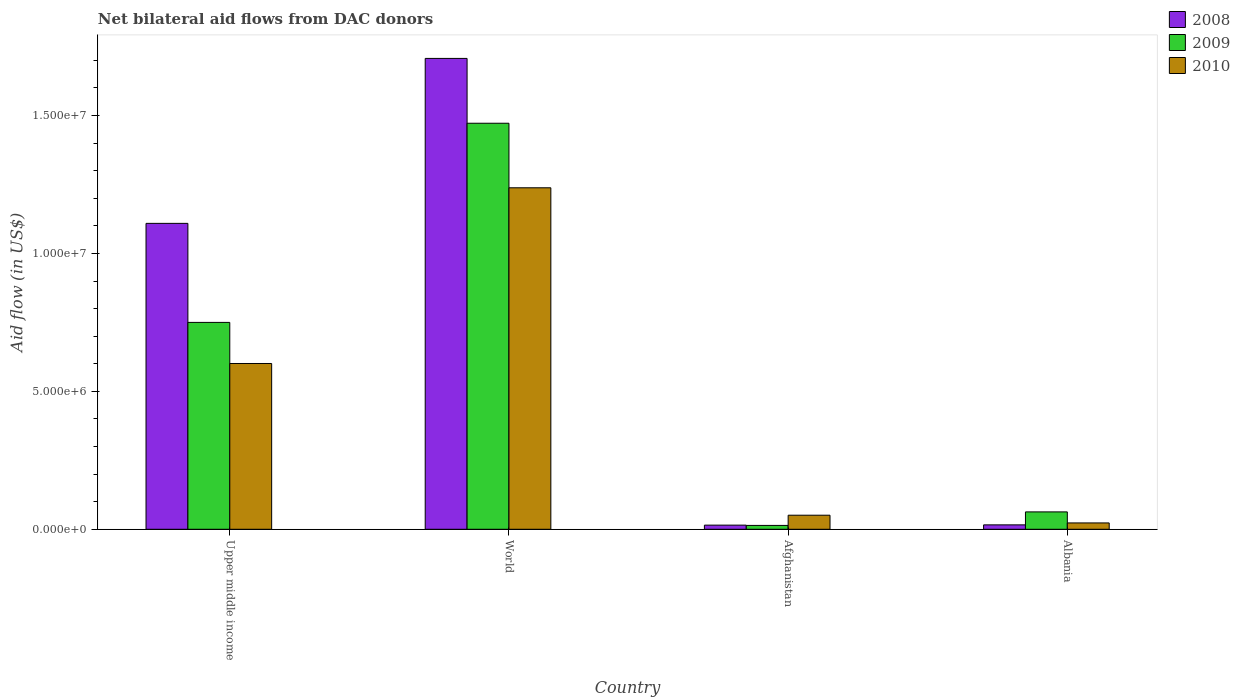Are the number of bars per tick equal to the number of legend labels?
Offer a terse response. Yes. How many bars are there on the 4th tick from the left?
Your response must be concise. 3. How many bars are there on the 4th tick from the right?
Your answer should be compact. 3. What is the label of the 3rd group of bars from the left?
Make the answer very short. Afghanistan. In how many cases, is the number of bars for a given country not equal to the number of legend labels?
Your answer should be very brief. 0. What is the net bilateral aid flow in 2009 in Upper middle income?
Provide a short and direct response. 7.50e+06. Across all countries, what is the maximum net bilateral aid flow in 2008?
Give a very brief answer. 1.71e+07. In which country was the net bilateral aid flow in 2008 minimum?
Your response must be concise. Afghanistan. What is the total net bilateral aid flow in 2010 in the graph?
Give a very brief answer. 1.91e+07. What is the difference between the net bilateral aid flow in 2008 in Afghanistan and that in World?
Your response must be concise. -1.69e+07. What is the difference between the net bilateral aid flow in 2009 in Upper middle income and the net bilateral aid flow in 2008 in World?
Your answer should be very brief. -9.57e+06. What is the average net bilateral aid flow in 2008 per country?
Offer a very short reply. 7.12e+06. In how many countries, is the net bilateral aid flow in 2010 greater than 7000000 US$?
Give a very brief answer. 1. What is the ratio of the net bilateral aid flow in 2010 in Upper middle income to that in World?
Your response must be concise. 0.49. Is the net bilateral aid flow in 2008 in Upper middle income less than that in World?
Keep it short and to the point. Yes. Is the difference between the net bilateral aid flow in 2009 in Albania and World greater than the difference between the net bilateral aid flow in 2010 in Albania and World?
Provide a short and direct response. No. What is the difference between the highest and the second highest net bilateral aid flow in 2008?
Offer a terse response. 1.69e+07. What is the difference between the highest and the lowest net bilateral aid flow in 2009?
Your response must be concise. 1.46e+07. In how many countries, is the net bilateral aid flow in 2009 greater than the average net bilateral aid flow in 2009 taken over all countries?
Your response must be concise. 2. Is the sum of the net bilateral aid flow in 2008 in Afghanistan and Upper middle income greater than the maximum net bilateral aid flow in 2009 across all countries?
Give a very brief answer. No. Is it the case that in every country, the sum of the net bilateral aid flow in 2009 and net bilateral aid flow in 2008 is greater than the net bilateral aid flow in 2010?
Provide a succinct answer. No. Are the values on the major ticks of Y-axis written in scientific E-notation?
Your response must be concise. Yes. Does the graph contain any zero values?
Offer a very short reply. No. Does the graph contain grids?
Keep it short and to the point. No. How are the legend labels stacked?
Your answer should be very brief. Vertical. What is the title of the graph?
Your answer should be very brief. Net bilateral aid flows from DAC donors. What is the label or title of the X-axis?
Your response must be concise. Country. What is the label or title of the Y-axis?
Provide a succinct answer. Aid flow (in US$). What is the Aid flow (in US$) in 2008 in Upper middle income?
Give a very brief answer. 1.11e+07. What is the Aid flow (in US$) in 2009 in Upper middle income?
Keep it short and to the point. 7.50e+06. What is the Aid flow (in US$) in 2010 in Upper middle income?
Offer a very short reply. 6.01e+06. What is the Aid flow (in US$) of 2008 in World?
Your answer should be compact. 1.71e+07. What is the Aid flow (in US$) in 2009 in World?
Your response must be concise. 1.47e+07. What is the Aid flow (in US$) in 2010 in World?
Your response must be concise. 1.24e+07. What is the Aid flow (in US$) in 2008 in Afghanistan?
Your answer should be compact. 1.50e+05. What is the Aid flow (in US$) of 2010 in Afghanistan?
Your answer should be compact. 5.10e+05. What is the Aid flow (in US$) in 2009 in Albania?
Give a very brief answer. 6.30e+05. What is the Aid flow (in US$) in 2010 in Albania?
Your answer should be very brief. 2.30e+05. Across all countries, what is the maximum Aid flow (in US$) of 2008?
Make the answer very short. 1.71e+07. Across all countries, what is the maximum Aid flow (in US$) of 2009?
Provide a short and direct response. 1.47e+07. Across all countries, what is the maximum Aid flow (in US$) of 2010?
Give a very brief answer. 1.24e+07. Across all countries, what is the minimum Aid flow (in US$) in 2008?
Ensure brevity in your answer.  1.50e+05. Across all countries, what is the minimum Aid flow (in US$) in 2010?
Your answer should be compact. 2.30e+05. What is the total Aid flow (in US$) in 2008 in the graph?
Your answer should be compact. 2.85e+07. What is the total Aid flow (in US$) in 2009 in the graph?
Make the answer very short. 2.30e+07. What is the total Aid flow (in US$) in 2010 in the graph?
Give a very brief answer. 1.91e+07. What is the difference between the Aid flow (in US$) of 2008 in Upper middle income and that in World?
Offer a terse response. -5.98e+06. What is the difference between the Aid flow (in US$) in 2009 in Upper middle income and that in World?
Offer a very short reply. -7.22e+06. What is the difference between the Aid flow (in US$) of 2010 in Upper middle income and that in World?
Offer a terse response. -6.37e+06. What is the difference between the Aid flow (in US$) in 2008 in Upper middle income and that in Afghanistan?
Your response must be concise. 1.09e+07. What is the difference between the Aid flow (in US$) of 2009 in Upper middle income and that in Afghanistan?
Offer a terse response. 7.36e+06. What is the difference between the Aid flow (in US$) of 2010 in Upper middle income and that in Afghanistan?
Your answer should be compact. 5.50e+06. What is the difference between the Aid flow (in US$) in 2008 in Upper middle income and that in Albania?
Give a very brief answer. 1.09e+07. What is the difference between the Aid flow (in US$) in 2009 in Upper middle income and that in Albania?
Ensure brevity in your answer.  6.87e+06. What is the difference between the Aid flow (in US$) in 2010 in Upper middle income and that in Albania?
Your response must be concise. 5.78e+06. What is the difference between the Aid flow (in US$) in 2008 in World and that in Afghanistan?
Offer a terse response. 1.69e+07. What is the difference between the Aid flow (in US$) of 2009 in World and that in Afghanistan?
Provide a succinct answer. 1.46e+07. What is the difference between the Aid flow (in US$) in 2010 in World and that in Afghanistan?
Give a very brief answer. 1.19e+07. What is the difference between the Aid flow (in US$) in 2008 in World and that in Albania?
Provide a short and direct response. 1.69e+07. What is the difference between the Aid flow (in US$) in 2009 in World and that in Albania?
Offer a terse response. 1.41e+07. What is the difference between the Aid flow (in US$) of 2010 in World and that in Albania?
Offer a terse response. 1.22e+07. What is the difference between the Aid flow (in US$) of 2009 in Afghanistan and that in Albania?
Make the answer very short. -4.90e+05. What is the difference between the Aid flow (in US$) of 2010 in Afghanistan and that in Albania?
Keep it short and to the point. 2.80e+05. What is the difference between the Aid flow (in US$) in 2008 in Upper middle income and the Aid flow (in US$) in 2009 in World?
Your response must be concise. -3.63e+06. What is the difference between the Aid flow (in US$) in 2008 in Upper middle income and the Aid flow (in US$) in 2010 in World?
Your response must be concise. -1.29e+06. What is the difference between the Aid flow (in US$) of 2009 in Upper middle income and the Aid flow (in US$) of 2010 in World?
Your response must be concise. -4.88e+06. What is the difference between the Aid flow (in US$) in 2008 in Upper middle income and the Aid flow (in US$) in 2009 in Afghanistan?
Make the answer very short. 1.10e+07. What is the difference between the Aid flow (in US$) in 2008 in Upper middle income and the Aid flow (in US$) in 2010 in Afghanistan?
Your answer should be compact. 1.06e+07. What is the difference between the Aid flow (in US$) in 2009 in Upper middle income and the Aid flow (in US$) in 2010 in Afghanistan?
Give a very brief answer. 6.99e+06. What is the difference between the Aid flow (in US$) in 2008 in Upper middle income and the Aid flow (in US$) in 2009 in Albania?
Your answer should be compact. 1.05e+07. What is the difference between the Aid flow (in US$) in 2008 in Upper middle income and the Aid flow (in US$) in 2010 in Albania?
Keep it short and to the point. 1.09e+07. What is the difference between the Aid flow (in US$) of 2009 in Upper middle income and the Aid flow (in US$) of 2010 in Albania?
Provide a succinct answer. 7.27e+06. What is the difference between the Aid flow (in US$) of 2008 in World and the Aid flow (in US$) of 2009 in Afghanistan?
Ensure brevity in your answer.  1.69e+07. What is the difference between the Aid flow (in US$) of 2008 in World and the Aid flow (in US$) of 2010 in Afghanistan?
Keep it short and to the point. 1.66e+07. What is the difference between the Aid flow (in US$) in 2009 in World and the Aid flow (in US$) in 2010 in Afghanistan?
Your response must be concise. 1.42e+07. What is the difference between the Aid flow (in US$) of 2008 in World and the Aid flow (in US$) of 2009 in Albania?
Give a very brief answer. 1.64e+07. What is the difference between the Aid flow (in US$) of 2008 in World and the Aid flow (in US$) of 2010 in Albania?
Ensure brevity in your answer.  1.68e+07. What is the difference between the Aid flow (in US$) of 2009 in World and the Aid flow (in US$) of 2010 in Albania?
Give a very brief answer. 1.45e+07. What is the difference between the Aid flow (in US$) of 2008 in Afghanistan and the Aid flow (in US$) of 2009 in Albania?
Offer a very short reply. -4.80e+05. What is the difference between the Aid flow (in US$) in 2009 in Afghanistan and the Aid flow (in US$) in 2010 in Albania?
Provide a short and direct response. -9.00e+04. What is the average Aid flow (in US$) of 2008 per country?
Your answer should be compact. 7.12e+06. What is the average Aid flow (in US$) in 2009 per country?
Keep it short and to the point. 5.75e+06. What is the average Aid flow (in US$) of 2010 per country?
Give a very brief answer. 4.78e+06. What is the difference between the Aid flow (in US$) in 2008 and Aid flow (in US$) in 2009 in Upper middle income?
Give a very brief answer. 3.59e+06. What is the difference between the Aid flow (in US$) of 2008 and Aid flow (in US$) of 2010 in Upper middle income?
Offer a very short reply. 5.08e+06. What is the difference between the Aid flow (in US$) of 2009 and Aid flow (in US$) of 2010 in Upper middle income?
Your response must be concise. 1.49e+06. What is the difference between the Aid flow (in US$) in 2008 and Aid flow (in US$) in 2009 in World?
Ensure brevity in your answer.  2.35e+06. What is the difference between the Aid flow (in US$) in 2008 and Aid flow (in US$) in 2010 in World?
Your answer should be very brief. 4.69e+06. What is the difference between the Aid flow (in US$) in 2009 and Aid flow (in US$) in 2010 in World?
Give a very brief answer. 2.34e+06. What is the difference between the Aid flow (in US$) in 2008 and Aid flow (in US$) in 2010 in Afghanistan?
Keep it short and to the point. -3.60e+05. What is the difference between the Aid flow (in US$) of 2009 and Aid flow (in US$) of 2010 in Afghanistan?
Your answer should be very brief. -3.70e+05. What is the difference between the Aid flow (in US$) in 2008 and Aid flow (in US$) in 2009 in Albania?
Keep it short and to the point. -4.70e+05. What is the difference between the Aid flow (in US$) in 2009 and Aid flow (in US$) in 2010 in Albania?
Offer a very short reply. 4.00e+05. What is the ratio of the Aid flow (in US$) of 2008 in Upper middle income to that in World?
Your answer should be very brief. 0.65. What is the ratio of the Aid flow (in US$) in 2009 in Upper middle income to that in World?
Make the answer very short. 0.51. What is the ratio of the Aid flow (in US$) in 2010 in Upper middle income to that in World?
Your answer should be very brief. 0.49. What is the ratio of the Aid flow (in US$) of 2008 in Upper middle income to that in Afghanistan?
Offer a very short reply. 73.93. What is the ratio of the Aid flow (in US$) in 2009 in Upper middle income to that in Afghanistan?
Your answer should be compact. 53.57. What is the ratio of the Aid flow (in US$) of 2010 in Upper middle income to that in Afghanistan?
Offer a very short reply. 11.78. What is the ratio of the Aid flow (in US$) in 2008 in Upper middle income to that in Albania?
Offer a very short reply. 69.31. What is the ratio of the Aid flow (in US$) of 2009 in Upper middle income to that in Albania?
Make the answer very short. 11.9. What is the ratio of the Aid flow (in US$) in 2010 in Upper middle income to that in Albania?
Provide a short and direct response. 26.13. What is the ratio of the Aid flow (in US$) of 2008 in World to that in Afghanistan?
Give a very brief answer. 113.8. What is the ratio of the Aid flow (in US$) of 2009 in World to that in Afghanistan?
Keep it short and to the point. 105.14. What is the ratio of the Aid flow (in US$) of 2010 in World to that in Afghanistan?
Provide a short and direct response. 24.27. What is the ratio of the Aid flow (in US$) of 2008 in World to that in Albania?
Provide a short and direct response. 106.69. What is the ratio of the Aid flow (in US$) in 2009 in World to that in Albania?
Make the answer very short. 23.37. What is the ratio of the Aid flow (in US$) in 2010 in World to that in Albania?
Your response must be concise. 53.83. What is the ratio of the Aid flow (in US$) in 2009 in Afghanistan to that in Albania?
Give a very brief answer. 0.22. What is the ratio of the Aid flow (in US$) of 2010 in Afghanistan to that in Albania?
Provide a short and direct response. 2.22. What is the difference between the highest and the second highest Aid flow (in US$) of 2008?
Your answer should be very brief. 5.98e+06. What is the difference between the highest and the second highest Aid flow (in US$) of 2009?
Offer a terse response. 7.22e+06. What is the difference between the highest and the second highest Aid flow (in US$) of 2010?
Provide a succinct answer. 6.37e+06. What is the difference between the highest and the lowest Aid flow (in US$) of 2008?
Keep it short and to the point. 1.69e+07. What is the difference between the highest and the lowest Aid flow (in US$) in 2009?
Ensure brevity in your answer.  1.46e+07. What is the difference between the highest and the lowest Aid flow (in US$) in 2010?
Make the answer very short. 1.22e+07. 